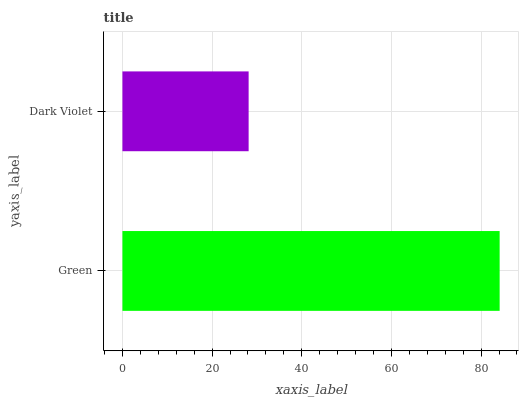Is Dark Violet the minimum?
Answer yes or no. Yes. Is Green the maximum?
Answer yes or no. Yes. Is Dark Violet the maximum?
Answer yes or no. No. Is Green greater than Dark Violet?
Answer yes or no. Yes. Is Dark Violet less than Green?
Answer yes or no. Yes. Is Dark Violet greater than Green?
Answer yes or no. No. Is Green less than Dark Violet?
Answer yes or no. No. Is Green the high median?
Answer yes or no. Yes. Is Dark Violet the low median?
Answer yes or no. Yes. Is Dark Violet the high median?
Answer yes or no. No. Is Green the low median?
Answer yes or no. No. 